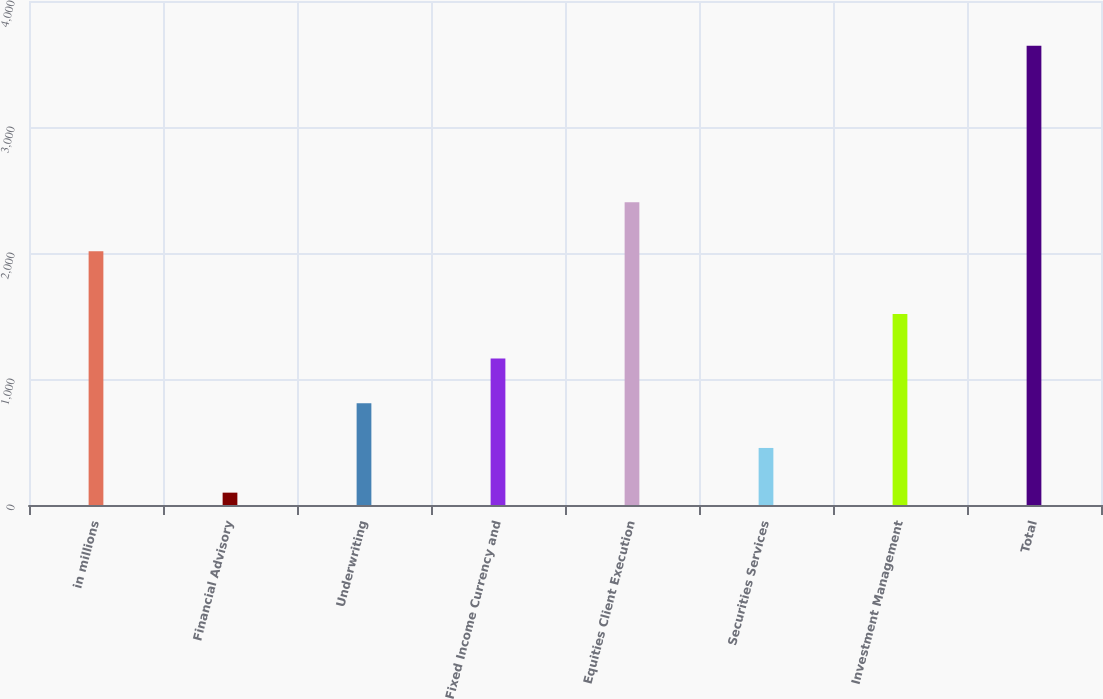<chart> <loc_0><loc_0><loc_500><loc_500><bar_chart><fcel>in millions<fcel>Financial Advisory<fcel>Underwriting<fcel>Fixed Income Currency and<fcel>Equities Client Execution<fcel>Securities Services<fcel>Investment Management<fcel>Total<nl><fcel>2014<fcel>98<fcel>807.4<fcel>1162.1<fcel>2403<fcel>452.7<fcel>1516.8<fcel>3645<nl></chart> 